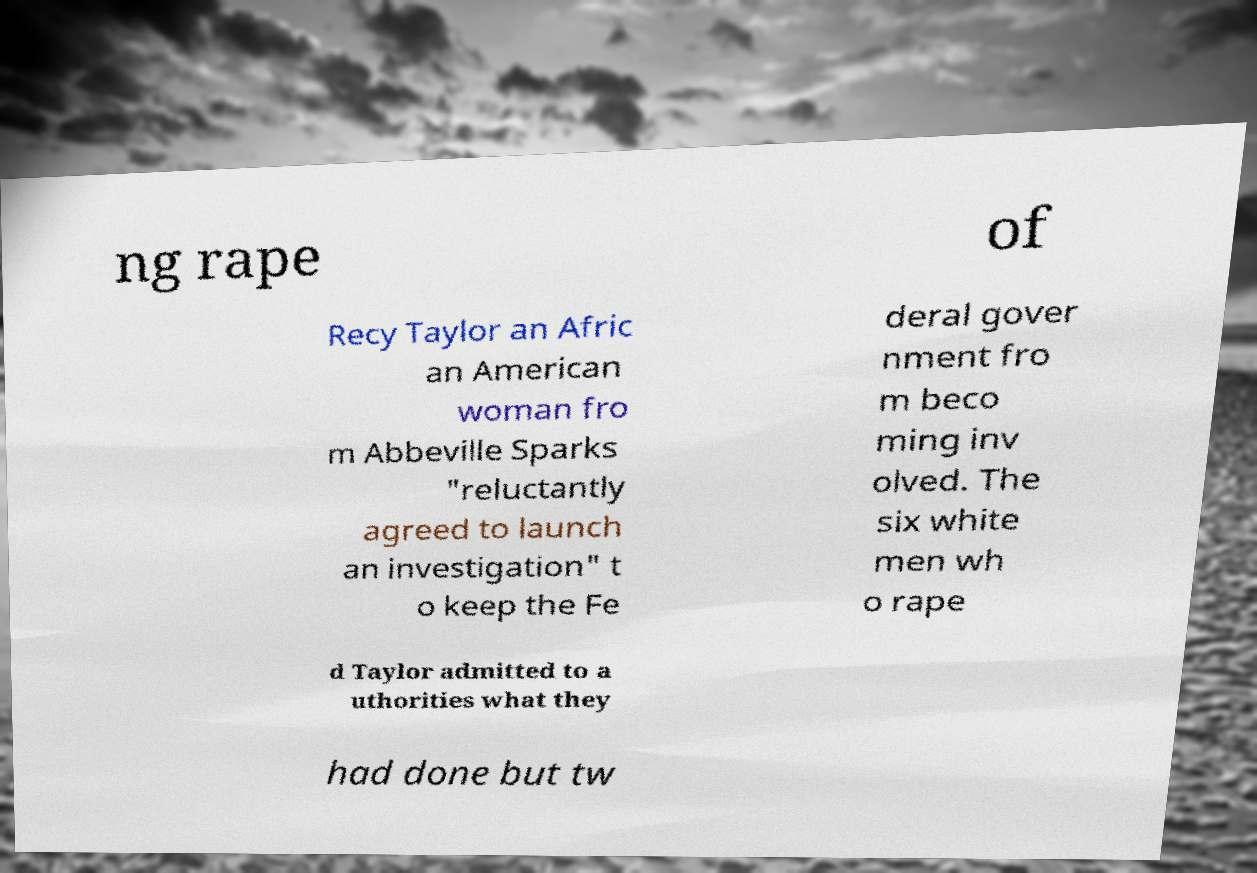For documentation purposes, I need the text within this image transcribed. Could you provide that? ng rape of Recy Taylor an Afric an American woman fro m Abbeville Sparks "reluctantly agreed to launch an investigation" t o keep the Fe deral gover nment fro m beco ming inv olved. The six white men wh o rape d Taylor admitted to a uthorities what they had done but tw 